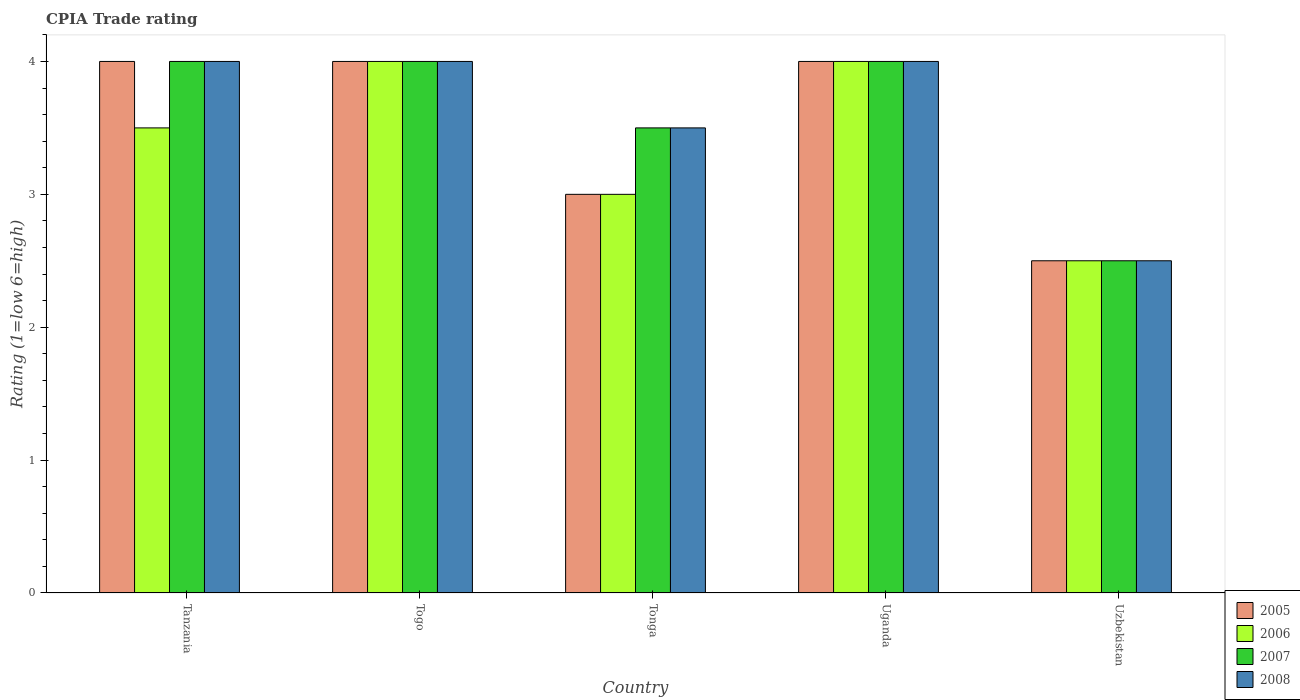How many groups of bars are there?
Your answer should be very brief. 5. Are the number of bars per tick equal to the number of legend labels?
Give a very brief answer. Yes. What is the label of the 5th group of bars from the left?
Your response must be concise. Uzbekistan. In how many cases, is the number of bars for a given country not equal to the number of legend labels?
Provide a short and direct response. 0. Across all countries, what is the maximum CPIA rating in 2006?
Ensure brevity in your answer.  4. Across all countries, what is the minimum CPIA rating in 2005?
Ensure brevity in your answer.  2.5. In which country was the CPIA rating in 2007 maximum?
Offer a very short reply. Tanzania. In which country was the CPIA rating in 2006 minimum?
Your answer should be compact. Uzbekistan. What is the total CPIA rating in 2006 in the graph?
Provide a succinct answer. 17. What is the difference between the CPIA rating in 2005 in Tanzania and that in Uganda?
Provide a succinct answer. 0. In how many countries, is the CPIA rating in 2006 greater than 1?
Your answer should be very brief. 5. What is the ratio of the CPIA rating in 2006 in Tanzania to that in Tonga?
Offer a terse response. 1.17. Is the difference between the CPIA rating in 2005 in Uganda and Uzbekistan greater than the difference between the CPIA rating in 2006 in Uganda and Uzbekistan?
Give a very brief answer. No. What does the 4th bar from the left in Tonga represents?
Keep it short and to the point. 2008. What does the 2nd bar from the right in Togo represents?
Your answer should be compact. 2007. Is it the case that in every country, the sum of the CPIA rating in 2008 and CPIA rating in 2007 is greater than the CPIA rating in 2006?
Ensure brevity in your answer.  Yes. How many bars are there?
Provide a succinct answer. 20. Are all the bars in the graph horizontal?
Your answer should be very brief. No. What is the difference between two consecutive major ticks on the Y-axis?
Keep it short and to the point. 1. Does the graph contain any zero values?
Make the answer very short. No. Does the graph contain grids?
Keep it short and to the point. No. Where does the legend appear in the graph?
Ensure brevity in your answer.  Bottom right. How many legend labels are there?
Provide a short and direct response. 4. How are the legend labels stacked?
Give a very brief answer. Vertical. What is the title of the graph?
Offer a very short reply. CPIA Trade rating. Does "2015" appear as one of the legend labels in the graph?
Give a very brief answer. No. What is the label or title of the X-axis?
Offer a terse response. Country. What is the Rating (1=low 6=high) of 2005 in Tanzania?
Your answer should be very brief. 4. What is the Rating (1=low 6=high) in 2006 in Tanzania?
Offer a very short reply. 3.5. What is the Rating (1=low 6=high) of 2007 in Tanzania?
Offer a terse response. 4. What is the Rating (1=low 6=high) in 2008 in Tanzania?
Give a very brief answer. 4. What is the Rating (1=low 6=high) in 2008 in Togo?
Offer a terse response. 4. What is the Rating (1=low 6=high) of 2007 in Tonga?
Your response must be concise. 3.5. What is the Rating (1=low 6=high) of 2005 in Uganda?
Make the answer very short. 4. What is the Rating (1=low 6=high) of 2006 in Uganda?
Provide a succinct answer. 4. What is the Rating (1=low 6=high) of 2007 in Uganda?
Offer a very short reply. 4. What is the Rating (1=low 6=high) of 2008 in Uganda?
Your response must be concise. 4. What is the Rating (1=low 6=high) in 2005 in Uzbekistan?
Keep it short and to the point. 2.5. What is the Rating (1=low 6=high) of 2006 in Uzbekistan?
Make the answer very short. 2.5. What is the Rating (1=low 6=high) of 2007 in Uzbekistan?
Your response must be concise. 2.5. What is the Rating (1=low 6=high) in 2008 in Uzbekistan?
Offer a very short reply. 2.5. Across all countries, what is the maximum Rating (1=low 6=high) of 2005?
Provide a short and direct response. 4. Across all countries, what is the maximum Rating (1=low 6=high) of 2008?
Give a very brief answer. 4. Across all countries, what is the minimum Rating (1=low 6=high) in 2005?
Offer a terse response. 2.5. What is the total Rating (1=low 6=high) of 2005 in the graph?
Your answer should be compact. 17.5. What is the total Rating (1=low 6=high) of 2006 in the graph?
Your answer should be very brief. 17. What is the total Rating (1=low 6=high) in 2007 in the graph?
Your answer should be compact. 18. What is the total Rating (1=low 6=high) in 2008 in the graph?
Offer a very short reply. 18. What is the difference between the Rating (1=low 6=high) of 2005 in Tanzania and that in Togo?
Provide a succinct answer. 0. What is the difference between the Rating (1=low 6=high) of 2005 in Tanzania and that in Tonga?
Give a very brief answer. 1. What is the difference between the Rating (1=low 6=high) of 2006 in Tanzania and that in Tonga?
Ensure brevity in your answer.  0.5. What is the difference between the Rating (1=low 6=high) in 2007 in Tanzania and that in Tonga?
Ensure brevity in your answer.  0.5. What is the difference between the Rating (1=low 6=high) of 2005 in Tanzania and that in Uganda?
Your answer should be very brief. 0. What is the difference between the Rating (1=low 6=high) of 2005 in Tanzania and that in Uzbekistan?
Keep it short and to the point. 1.5. What is the difference between the Rating (1=low 6=high) in 2008 in Tanzania and that in Uzbekistan?
Ensure brevity in your answer.  1.5. What is the difference between the Rating (1=low 6=high) of 2005 in Togo and that in Tonga?
Provide a short and direct response. 1. What is the difference between the Rating (1=low 6=high) of 2008 in Togo and that in Uganda?
Your response must be concise. 0. What is the difference between the Rating (1=low 6=high) in 2005 in Togo and that in Uzbekistan?
Your response must be concise. 1.5. What is the difference between the Rating (1=low 6=high) of 2008 in Togo and that in Uzbekistan?
Offer a terse response. 1.5. What is the difference between the Rating (1=low 6=high) in 2005 in Tonga and that in Uganda?
Your response must be concise. -1. What is the difference between the Rating (1=low 6=high) of 2006 in Tonga and that in Uganda?
Give a very brief answer. -1. What is the difference between the Rating (1=low 6=high) in 2007 in Tonga and that in Uganda?
Your response must be concise. -0.5. What is the difference between the Rating (1=low 6=high) of 2005 in Tonga and that in Uzbekistan?
Make the answer very short. 0.5. What is the difference between the Rating (1=low 6=high) in 2007 in Tonga and that in Uzbekistan?
Provide a short and direct response. 1. What is the difference between the Rating (1=low 6=high) in 2005 in Uganda and that in Uzbekistan?
Give a very brief answer. 1.5. What is the difference between the Rating (1=low 6=high) of 2005 in Tanzania and the Rating (1=low 6=high) of 2006 in Togo?
Keep it short and to the point. 0. What is the difference between the Rating (1=low 6=high) in 2005 in Tanzania and the Rating (1=low 6=high) in 2007 in Togo?
Provide a short and direct response. 0. What is the difference between the Rating (1=low 6=high) in 2006 in Tanzania and the Rating (1=low 6=high) in 2007 in Tonga?
Provide a short and direct response. 0. What is the difference between the Rating (1=low 6=high) of 2006 in Tanzania and the Rating (1=low 6=high) of 2008 in Tonga?
Your answer should be very brief. 0. What is the difference between the Rating (1=low 6=high) in 2006 in Tanzania and the Rating (1=low 6=high) in 2008 in Uganda?
Give a very brief answer. -0.5. What is the difference between the Rating (1=low 6=high) of 2005 in Tanzania and the Rating (1=low 6=high) of 2007 in Uzbekistan?
Provide a short and direct response. 1.5. What is the difference between the Rating (1=low 6=high) in 2005 in Tanzania and the Rating (1=low 6=high) in 2008 in Uzbekistan?
Give a very brief answer. 1.5. What is the difference between the Rating (1=low 6=high) of 2006 in Tanzania and the Rating (1=low 6=high) of 2008 in Uzbekistan?
Make the answer very short. 1. What is the difference between the Rating (1=low 6=high) in 2005 in Togo and the Rating (1=low 6=high) in 2006 in Tonga?
Ensure brevity in your answer.  1. What is the difference between the Rating (1=low 6=high) in 2005 in Togo and the Rating (1=low 6=high) in 2007 in Tonga?
Provide a short and direct response. 0.5. What is the difference between the Rating (1=low 6=high) in 2005 in Togo and the Rating (1=low 6=high) in 2008 in Tonga?
Provide a short and direct response. 0.5. What is the difference between the Rating (1=low 6=high) of 2007 in Togo and the Rating (1=low 6=high) of 2008 in Tonga?
Offer a terse response. 0.5. What is the difference between the Rating (1=low 6=high) in 2005 in Togo and the Rating (1=low 6=high) in 2006 in Uganda?
Keep it short and to the point. 0. What is the difference between the Rating (1=low 6=high) in 2005 in Togo and the Rating (1=low 6=high) in 2007 in Uganda?
Give a very brief answer. 0. What is the difference between the Rating (1=low 6=high) of 2005 in Togo and the Rating (1=low 6=high) of 2008 in Uganda?
Offer a very short reply. 0. What is the difference between the Rating (1=low 6=high) in 2006 in Togo and the Rating (1=low 6=high) in 2007 in Uganda?
Your answer should be very brief. 0. What is the difference between the Rating (1=low 6=high) of 2006 in Togo and the Rating (1=low 6=high) of 2008 in Uganda?
Your answer should be very brief. 0. What is the difference between the Rating (1=low 6=high) in 2006 in Togo and the Rating (1=low 6=high) in 2007 in Uzbekistan?
Keep it short and to the point. 1.5. What is the difference between the Rating (1=low 6=high) in 2007 in Togo and the Rating (1=low 6=high) in 2008 in Uzbekistan?
Offer a very short reply. 1.5. What is the difference between the Rating (1=low 6=high) of 2005 in Tonga and the Rating (1=low 6=high) of 2006 in Uganda?
Provide a short and direct response. -1. What is the difference between the Rating (1=low 6=high) in 2006 in Tonga and the Rating (1=low 6=high) in 2007 in Uganda?
Your answer should be very brief. -1. What is the difference between the Rating (1=low 6=high) in 2007 in Tonga and the Rating (1=low 6=high) in 2008 in Uganda?
Your answer should be compact. -0.5. What is the difference between the Rating (1=low 6=high) of 2005 in Tonga and the Rating (1=low 6=high) of 2006 in Uzbekistan?
Provide a succinct answer. 0.5. What is the difference between the Rating (1=low 6=high) in 2005 in Tonga and the Rating (1=low 6=high) in 2007 in Uzbekistan?
Provide a short and direct response. 0.5. What is the difference between the Rating (1=low 6=high) of 2005 in Tonga and the Rating (1=low 6=high) of 2008 in Uzbekistan?
Offer a very short reply. 0.5. What is the difference between the Rating (1=low 6=high) in 2007 in Tonga and the Rating (1=low 6=high) in 2008 in Uzbekistan?
Give a very brief answer. 1. What is the difference between the Rating (1=low 6=high) in 2005 in Uganda and the Rating (1=low 6=high) in 2007 in Uzbekistan?
Your answer should be very brief. 1.5. What is the difference between the Rating (1=low 6=high) of 2005 in Uganda and the Rating (1=low 6=high) of 2008 in Uzbekistan?
Provide a succinct answer. 1.5. What is the difference between the Rating (1=low 6=high) of 2006 in Uganda and the Rating (1=low 6=high) of 2008 in Uzbekistan?
Offer a very short reply. 1.5. What is the average Rating (1=low 6=high) in 2005 per country?
Your response must be concise. 3.5. What is the average Rating (1=low 6=high) in 2006 per country?
Your answer should be compact. 3.4. What is the average Rating (1=low 6=high) in 2008 per country?
Offer a very short reply. 3.6. What is the difference between the Rating (1=low 6=high) of 2005 and Rating (1=low 6=high) of 2007 in Tanzania?
Provide a short and direct response. 0. What is the difference between the Rating (1=low 6=high) in 2005 and Rating (1=low 6=high) in 2008 in Tanzania?
Offer a very short reply. 0. What is the difference between the Rating (1=low 6=high) in 2006 and Rating (1=low 6=high) in 2007 in Tanzania?
Keep it short and to the point. -0.5. What is the difference between the Rating (1=low 6=high) of 2005 and Rating (1=low 6=high) of 2006 in Togo?
Your answer should be compact. 0. What is the difference between the Rating (1=low 6=high) of 2005 and Rating (1=low 6=high) of 2007 in Togo?
Keep it short and to the point. 0. What is the difference between the Rating (1=low 6=high) of 2006 and Rating (1=low 6=high) of 2008 in Togo?
Provide a succinct answer. 0. What is the difference between the Rating (1=low 6=high) of 2005 and Rating (1=low 6=high) of 2006 in Tonga?
Offer a very short reply. 0. What is the difference between the Rating (1=low 6=high) of 2006 and Rating (1=low 6=high) of 2007 in Tonga?
Provide a succinct answer. -0.5. What is the difference between the Rating (1=low 6=high) in 2005 and Rating (1=low 6=high) in 2007 in Uganda?
Keep it short and to the point. 0. What is the difference between the Rating (1=low 6=high) in 2005 and Rating (1=low 6=high) in 2008 in Uganda?
Offer a terse response. 0. What is the difference between the Rating (1=low 6=high) in 2006 and Rating (1=low 6=high) in 2007 in Uganda?
Your response must be concise. 0. What is the difference between the Rating (1=low 6=high) of 2005 and Rating (1=low 6=high) of 2006 in Uzbekistan?
Ensure brevity in your answer.  0. What is the difference between the Rating (1=low 6=high) in 2005 and Rating (1=low 6=high) in 2007 in Uzbekistan?
Offer a very short reply. 0. What is the difference between the Rating (1=low 6=high) in 2006 and Rating (1=low 6=high) in 2008 in Uzbekistan?
Offer a terse response. 0. What is the difference between the Rating (1=low 6=high) of 2007 and Rating (1=low 6=high) of 2008 in Uzbekistan?
Give a very brief answer. 0. What is the ratio of the Rating (1=low 6=high) of 2006 in Tanzania to that in Togo?
Your answer should be compact. 0.88. What is the ratio of the Rating (1=low 6=high) of 2008 in Tanzania to that in Togo?
Provide a short and direct response. 1. What is the ratio of the Rating (1=low 6=high) in 2006 in Tanzania to that in Tonga?
Your answer should be very brief. 1.17. What is the ratio of the Rating (1=low 6=high) in 2005 in Tanzania to that in Uganda?
Your answer should be very brief. 1. What is the ratio of the Rating (1=low 6=high) of 2006 in Tanzania to that in Uganda?
Your answer should be very brief. 0.88. What is the ratio of the Rating (1=low 6=high) of 2007 in Tanzania to that in Uganda?
Make the answer very short. 1. What is the ratio of the Rating (1=low 6=high) of 2007 in Tanzania to that in Uzbekistan?
Offer a very short reply. 1.6. What is the ratio of the Rating (1=low 6=high) in 2006 in Togo to that in Tonga?
Your answer should be very brief. 1.33. What is the ratio of the Rating (1=low 6=high) of 2008 in Togo to that in Tonga?
Your response must be concise. 1.14. What is the ratio of the Rating (1=low 6=high) in 2006 in Togo to that in Uzbekistan?
Your response must be concise. 1.6. What is the ratio of the Rating (1=low 6=high) of 2007 in Togo to that in Uzbekistan?
Provide a short and direct response. 1.6. What is the ratio of the Rating (1=low 6=high) of 2006 in Tonga to that in Uzbekistan?
Offer a terse response. 1.2. What is the ratio of the Rating (1=low 6=high) of 2007 in Tonga to that in Uzbekistan?
Make the answer very short. 1.4. What is the ratio of the Rating (1=low 6=high) in 2008 in Tonga to that in Uzbekistan?
Provide a succinct answer. 1.4. What is the ratio of the Rating (1=low 6=high) of 2006 in Uganda to that in Uzbekistan?
Keep it short and to the point. 1.6. What is the ratio of the Rating (1=low 6=high) in 2007 in Uganda to that in Uzbekistan?
Provide a succinct answer. 1.6. What is the ratio of the Rating (1=low 6=high) in 2008 in Uganda to that in Uzbekistan?
Your response must be concise. 1.6. What is the difference between the highest and the second highest Rating (1=low 6=high) in 2005?
Give a very brief answer. 0. What is the difference between the highest and the second highest Rating (1=low 6=high) of 2006?
Provide a succinct answer. 0. What is the difference between the highest and the lowest Rating (1=low 6=high) of 2005?
Your answer should be compact. 1.5. What is the difference between the highest and the lowest Rating (1=low 6=high) of 2007?
Give a very brief answer. 1.5. 